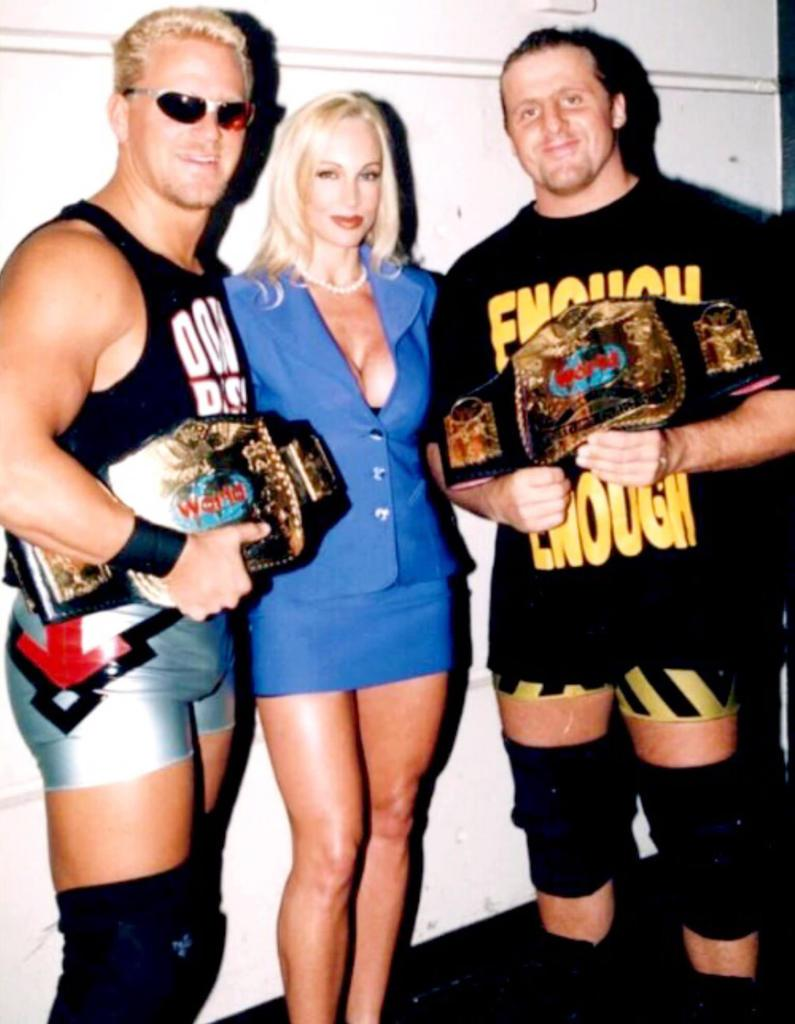<image>
Describe the image concisely. Two wrestlers with championship belts, one wearing a shirt that says Enough, standing next to a woman. 